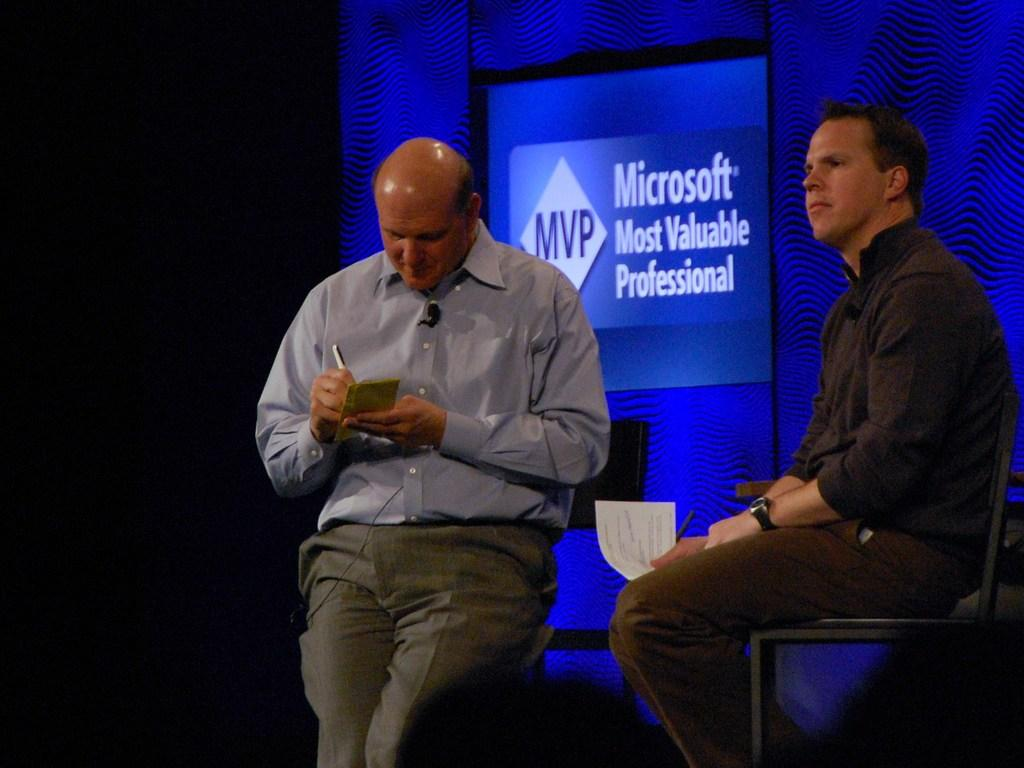How many people are in the image? There are two persons in the image. What are the persons doing in the image? The persons are sitting on chairs. What can be seen in the background of the image? There is some text visible in the background, and the background color is blue. How many legs does the creature have in the image? There is no creature present in the image, so it is not possible to determine the number of legs it might have. 